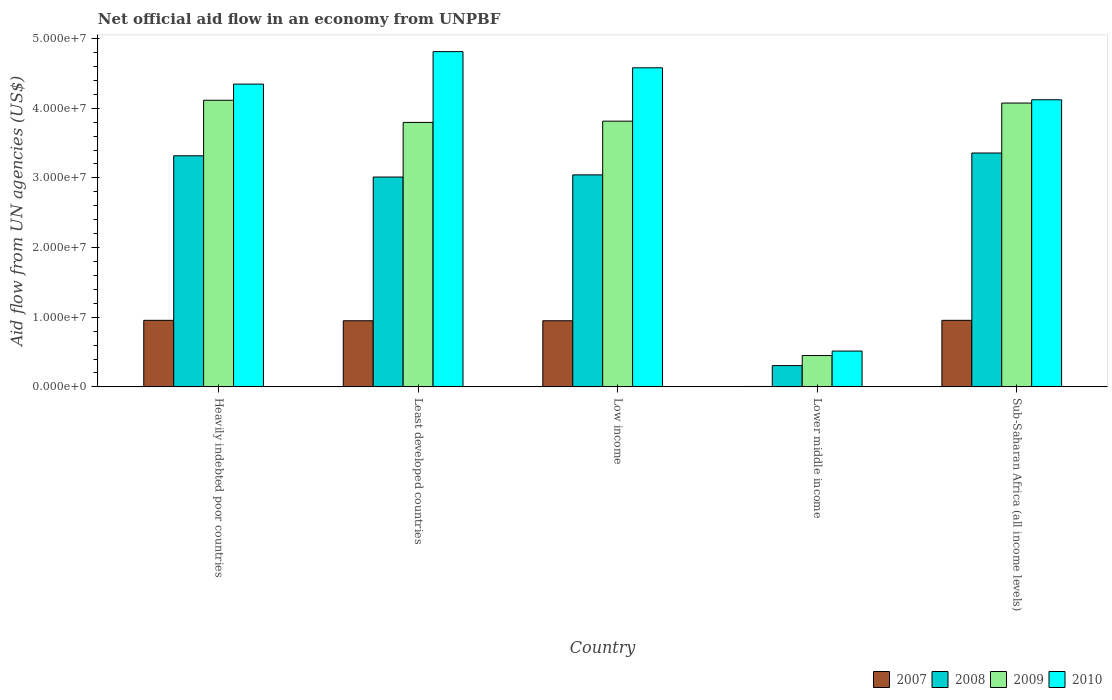Are the number of bars per tick equal to the number of legend labels?
Give a very brief answer. Yes. How many bars are there on the 2nd tick from the left?
Ensure brevity in your answer.  4. What is the label of the 4th group of bars from the left?
Your response must be concise. Lower middle income. In how many cases, is the number of bars for a given country not equal to the number of legend labels?
Offer a terse response. 0. What is the net official aid flow in 2008 in Least developed countries?
Provide a succinct answer. 3.01e+07. Across all countries, what is the maximum net official aid flow in 2009?
Your response must be concise. 4.11e+07. Across all countries, what is the minimum net official aid flow in 2009?
Make the answer very short. 4.50e+06. In which country was the net official aid flow in 2007 maximum?
Your answer should be very brief. Heavily indebted poor countries. In which country was the net official aid flow in 2010 minimum?
Provide a short and direct response. Lower middle income. What is the total net official aid flow in 2010 in the graph?
Your answer should be very brief. 1.84e+08. What is the difference between the net official aid flow in 2010 in Sub-Saharan Africa (all income levels) and the net official aid flow in 2008 in Least developed countries?
Keep it short and to the point. 1.11e+07. What is the average net official aid flow in 2007 per country?
Keep it short and to the point. 7.63e+06. What is the difference between the net official aid flow of/in 2009 and net official aid flow of/in 2010 in Sub-Saharan Africa (all income levels)?
Offer a very short reply. -4.70e+05. What is the ratio of the net official aid flow in 2010 in Heavily indebted poor countries to that in Least developed countries?
Your answer should be very brief. 0.9. Is the difference between the net official aid flow in 2009 in Lower middle income and Sub-Saharan Africa (all income levels) greater than the difference between the net official aid flow in 2010 in Lower middle income and Sub-Saharan Africa (all income levels)?
Offer a very short reply. No. What is the difference between the highest and the second highest net official aid flow in 2009?
Your answer should be very brief. 3.00e+06. What is the difference between the highest and the lowest net official aid flow in 2008?
Your response must be concise. 3.05e+07. In how many countries, is the net official aid flow in 2008 greater than the average net official aid flow in 2008 taken over all countries?
Your answer should be compact. 4. Is it the case that in every country, the sum of the net official aid flow in 2010 and net official aid flow in 2008 is greater than the sum of net official aid flow in 2007 and net official aid flow in 2009?
Your answer should be very brief. No. What does the 2nd bar from the left in Lower middle income represents?
Your answer should be compact. 2008. What does the 4th bar from the right in Heavily indebted poor countries represents?
Your answer should be compact. 2007. Is it the case that in every country, the sum of the net official aid flow in 2007 and net official aid flow in 2010 is greater than the net official aid flow in 2009?
Offer a terse response. Yes. What is the difference between two consecutive major ticks on the Y-axis?
Offer a terse response. 1.00e+07. Are the values on the major ticks of Y-axis written in scientific E-notation?
Provide a short and direct response. Yes. Does the graph contain any zero values?
Make the answer very short. No. Does the graph contain grids?
Your response must be concise. No. How many legend labels are there?
Provide a short and direct response. 4. What is the title of the graph?
Give a very brief answer. Net official aid flow in an economy from UNPBF. Does "2002" appear as one of the legend labels in the graph?
Offer a terse response. No. What is the label or title of the X-axis?
Your answer should be compact. Country. What is the label or title of the Y-axis?
Provide a short and direct response. Aid flow from UN agencies (US$). What is the Aid flow from UN agencies (US$) of 2007 in Heavily indebted poor countries?
Make the answer very short. 9.55e+06. What is the Aid flow from UN agencies (US$) in 2008 in Heavily indebted poor countries?
Give a very brief answer. 3.32e+07. What is the Aid flow from UN agencies (US$) of 2009 in Heavily indebted poor countries?
Provide a succinct answer. 4.11e+07. What is the Aid flow from UN agencies (US$) of 2010 in Heavily indebted poor countries?
Your answer should be very brief. 4.35e+07. What is the Aid flow from UN agencies (US$) in 2007 in Least developed countries?
Offer a very short reply. 9.49e+06. What is the Aid flow from UN agencies (US$) of 2008 in Least developed countries?
Your response must be concise. 3.01e+07. What is the Aid flow from UN agencies (US$) of 2009 in Least developed countries?
Your answer should be compact. 3.80e+07. What is the Aid flow from UN agencies (US$) in 2010 in Least developed countries?
Keep it short and to the point. 4.81e+07. What is the Aid flow from UN agencies (US$) in 2007 in Low income?
Your answer should be very brief. 9.49e+06. What is the Aid flow from UN agencies (US$) of 2008 in Low income?
Give a very brief answer. 3.04e+07. What is the Aid flow from UN agencies (US$) in 2009 in Low income?
Make the answer very short. 3.81e+07. What is the Aid flow from UN agencies (US$) of 2010 in Low income?
Ensure brevity in your answer.  4.58e+07. What is the Aid flow from UN agencies (US$) in 2007 in Lower middle income?
Give a very brief answer. 6.00e+04. What is the Aid flow from UN agencies (US$) in 2008 in Lower middle income?
Your answer should be very brief. 3.05e+06. What is the Aid flow from UN agencies (US$) of 2009 in Lower middle income?
Your response must be concise. 4.50e+06. What is the Aid flow from UN agencies (US$) in 2010 in Lower middle income?
Your answer should be compact. 5.14e+06. What is the Aid flow from UN agencies (US$) in 2007 in Sub-Saharan Africa (all income levels)?
Provide a succinct answer. 9.55e+06. What is the Aid flow from UN agencies (US$) in 2008 in Sub-Saharan Africa (all income levels)?
Offer a very short reply. 3.36e+07. What is the Aid flow from UN agencies (US$) of 2009 in Sub-Saharan Africa (all income levels)?
Give a very brief answer. 4.07e+07. What is the Aid flow from UN agencies (US$) of 2010 in Sub-Saharan Africa (all income levels)?
Provide a succinct answer. 4.12e+07. Across all countries, what is the maximum Aid flow from UN agencies (US$) in 2007?
Your answer should be compact. 9.55e+06. Across all countries, what is the maximum Aid flow from UN agencies (US$) in 2008?
Your answer should be compact. 3.36e+07. Across all countries, what is the maximum Aid flow from UN agencies (US$) in 2009?
Give a very brief answer. 4.11e+07. Across all countries, what is the maximum Aid flow from UN agencies (US$) of 2010?
Your answer should be compact. 4.81e+07. Across all countries, what is the minimum Aid flow from UN agencies (US$) in 2008?
Ensure brevity in your answer.  3.05e+06. Across all countries, what is the minimum Aid flow from UN agencies (US$) in 2009?
Your response must be concise. 4.50e+06. Across all countries, what is the minimum Aid flow from UN agencies (US$) of 2010?
Offer a terse response. 5.14e+06. What is the total Aid flow from UN agencies (US$) of 2007 in the graph?
Make the answer very short. 3.81e+07. What is the total Aid flow from UN agencies (US$) in 2008 in the graph?
Your response must be concise. 1.30e+08. What is the total Aid flow from UN agencies (US$) of 2009 in the graph?
Your answer should be compact. 1.62e+08. What is the total Aid flow from UN agencies (US$) of 2010 in the graph?
Your answer should be very brief. 1.84e+08. What is the difference between the Aid flow from UN agencies (US$) in 2008 in Heavily indebted poor countries and that in Least developed countries?
Provide a short and direct response. 3.05e+06. What is the difference between the Aid flow from UN agencies (US$) in 2009 in Heavily indebted poor countries and that in Least developed countries?
Ensure brevity in your answer.  3.18e+06. What is the difference between the Aid flow from UN agencies (US$) of 2010 in Heavily indebted poor countries and that in Least developed countries?
Ensure brevity in your answer.  -4.66e+06. What is the difference between the Aid flow from UN agencies (US$) of 2007 in Heavily indebted poor countries and that in Low income?
Your answer should be compact. 6.00e+04. What is the difference between the Aid flow from UN agencies (US$) of 2008 in Heavily indebted poor countries and that in Low income?
Ensure brevity in your answer.  2.74e+06. What is the difference between the Aid flow from UN agencies (US$) of 2010 in Heavily indebted poor countries and that in Low income?
Your response must be concise. -2.34e+06. What is the difference between the Aid flow from UN agencies (US$) in 2007 in Heavily indebted poor countries and that in Lower middle income?
Offer a very short reply. 9.49e+06. What is the difference between the Aid flow from UN agencies (US$) in 2008 in Heavily indebted poor countries and that in Lower middle income?
Provide a short and direct response. 3.01e+07. What is the difference between the Aid flow from UN agencies (US$) in 2009 in Heavily indebted poor countries and that in Lower middle income?
Keep it short and to the point. 3.66e+07. What is the difference between the Aid flow from UN agencies (US$) in 2010 in Heavily indebted poor countries and that in Lower middle income?
Your answer should be very brief. 3.83e+07. What is the difference between the Aid flow from UN agencies (US$) in 2008 in Heavily indebted poor countries and that in Sub-Saharan Africa (all income levels)?
Your response must be concise. -4.00e+05. What is the difference between the Aid flow from UN agencies (US$) in 2009 in Heavily indebted poor countries and that in Sub-Saharan Africa (all income levels)?
Provide a succinct answer. 4.00e+05. What is the difference between the Aid flow from UN agencies (US$) in 2010 in Heavily indebted poor countries and that in Sub-Saharan Africa (all income levels)?
Your answer should be very brief. 2.25e+06. What is the difference between the Aid flow from UN agencies (US$) of 2007 in Least developed countries and that in Low income?
Your answer should be very brief. 0. What is the difference between the Aid flow from UN agencies (US$) in 2008 in Least developed countries and that in Low income?
Provide a short and direct response. -3.10e+05. What is the difference between the Aid flow from UN agencies (US$) in 2009 in Least developed countries and that in Low income?
Keep it short and to the point. -1.80e+05. What is the difference between the Aid flow from UN agencies (US$) in 2010 in Least developed countries and that in Low income?
Provide a short and direct response. 2.32e+06. What is the difference between the Aid flow from UN agencies (US$) in 2007 in Least developed countries and that in Lower middle income?
Offer a very short reply. 9.43e+06. What is the difference between the Aid flow from UN agencies (US$) of 2008 in Least developed countries and that in Lower middle income?
Offer a terse response. 2.71e+07. What is the difference between the Aid flow from UN agencies (US$) of 2009 in Least developed countries and that in Lower middle income?
Your answer should be compact. 3.35e+07. What is the difference between the Aid flow from UN agencies (US$) of 2010 in Least developed countries and that in Lower middle income?
Provide a short and direct response. 4.30e+07. What is the difference between the Aid flow from UN agencies (US$) in 2008 in Least developed countries and that in Sub-Saharan Africa (all income levels)?
Your answer should be compact. -3.45e+06. What is the difference between the Aid flow from UN agencies (US$) of 2009 in Least developed countries and that in Sub-Saharan Africa (all income levels)?
Give a very brief answer. -2.78e+06. What is the difference between the Aid flow from UN agencies (US$) of 2010 in Least developed countries and that in Sub-Saharan Africa (all income levels)?
Ensure brevity in your answer.  6.91e+06. What is the difference between the Aid flow from UN agencies (US$) of 2007 in Low income and that in Lower middle income?
Your answer should be compact. 9.43e+06. What is the difference between the Aid flow from UN agencies (US$) in 2008 in Low income and that in Lower middle income?
Offer a very short reply. 2.74e+07. What is the difference between the Aid flow from UN agencies (US$) in 2009 in Low income and that in Lower middle income?
Your answer should be compact. 3.36e+07. What is the difference between the Aid flow from UN agencies (US$) in 2010 in Low income and that in Lower middle income?
Provide a short and direct response. 4.07e+07. What is the difference between the Aid flow from UN agencies (US$) in 2008 in Low income and that in Sub-Saharan Africa (all income levels)?
Your answer should be compact. -3.14e+06. What is the difference between the Aid flow from UN agencies (US$) of 2009 in Low income and that in Sub-Saharan Africa (all income levels)?
Ensure brevity in your answer.  -2.60e+06. What is the difference between the Aid flow from UN agencies (US$) of 2010 in Low income and that in Sub-Saharan Africa (all income levels)?
Your answer should be compact. 4.59e+06. What is the difference between the Aid flow from UN agencies (US$) in 2007 in Lower middle income and that in Sub-Saharan Africa (all income levels)?
Offer a terse response. -9.49e+06. What is the difference between the Aid flow from UN agencies (US$) in 2008 in Lower middle income and that in Sub-Saharan Africa (all income levels)?
Keep it short and to the point. -3.05e+07. What is the difference between the Aid flow from UN agencies (US$) in 2009 in Lower middle income and that in Sub-Saharan Africa (all income levels)?
Provide a succinct answer. -3.62e+07. What is the difference between the Aid flow from UN agencies (US$) of 2010 in Lower middle income and that in Sub-Saharan Africa (all income levels)?
Your response must be concise. -3.61e+07. What is the difference between the Aid flow from UN agencies (US$) of 2007 in Heavily indebted poor countries and the Aid flow from UN agencies (US$) of 2008 in Least developed countries?
Provide a succinct answer. -2.06e+07. What is the difference between the Aid flow from UN agencies (US$) in 2007 in Heavily indebted poor countries and the Aid flow from UN agencies (US$) in 2009 in Least developed countries?
Give a very brief answer. -2.84e+07. What is the difference between the Aid flow from UN agencies (US$) of 2007 in Heavily indebted poor countries and the Aid flow from UN agencies (US$) of 2010 in Least developed countries?
Provide a succinct answer. -3.86e+07. What is the difference between the Aid flow from UN agencies (US$) in 2008 in Heavily indebted poor countries and the Aid flow from UN agencies (US$) in 2009 in Least developed countries?
Offer a very short reply. -4.79e+06. What is the difference between the Aid flow from UN agencies (US$) in 2008 in Heavily indebted poor countries and the Aid flow from UN agencies (US$) in 2010 in Least developed countries?
Ensure brevity in your answer.  -1.50e+07. What is the difference between the Aid flow from UN agencies (US$) of 2009 in Heavily indebted poor countries and the Aid flow from UN agencies (US$) of 2010 in Least developed countries?
Give a very brief answer. -6.98e+06. What is the difference between the Aid flow from UN agencies (US$) in 2007 in Heavily indebted poor countries and the Aid flow from UN agencies (US$) in 2008 in Low income?
Offer a terse response. -2.09e+07. What is the difference between the Aid flow from UN agencies (US$) in 2007 in Heavily indebted poor countries and the Aid flow from UN agencies (US$) in 2009 in Low income?
Provide a succinct answer. -2.86e+07. What is the difference between the Aid flow from UN agencies (US$) of 2007 in Heavily indebted poor countries and the Aid flow from UN agencies (US$) of 2010 in Low income?
Provide a succinct answer. -3.62e+07. What is the difference between the Aid flow from UN agencies (US$) of 2008 in Heavily indebted poor countries and the Aid flow from UN agencies (US$) of 2009 in Low income?
Your response must be concise. -4.97e+06. What is the difference between the Aid flow from UN agencies (US$) in 2008 in Heavily indebted poor countries and the Aid flow from UN agencies (US$) in 2010 in Low income?
Keep it short and to the point. -1.26e+07. What is the difference between the Aid flow from UN agencies (US$) in 2009 in Heavily indebted poor countries and the Aid flow from UN agencies (US$) in 2010 in Low income?
Provide a short and direct response. -4.66e+06. What is the difference between the Aid flow from UN agencies (US$) in 2007 in Heavily indebted poor countries and the Aid flow from UN agencies (US$) in 2008 in Lower middle income?
Ensure brevity in your answer.  6.50e+06. What is the difference between the Aid flow from UN agencies (US$) in 2007 in Heavily indebted poor countries and the Aid flow from UN agencies (US$) in 2009 in Lower middle income?
Your answer should be very brief. 5.05e+06. What is the difference between the Aid flow from UN agencies (US$) in 2007 in Heavily indebted poor countries and the Aid flow from UN agencies (US$) in 2010 in Lower middle income?
Provide a short and direct response. 4.41e+06. What is the difference between the Aid flow from UN agencies (US$) of 2008 in Heavily indebted poor countries and the Aid flow from UN agencies (US$) of 2009 in Lower middle income?
Your answer should be very brief. 2.87e+07. What is the difference between the Aid flow from UN agencies (US$) of 2008 in Heavily indebted poor countries and the Aid flow from UN agencies (US$) of 2010 in Lower middle income?
Provide a succinct answer. 2.80e+07. What is the difference between the Aid flow from UN agencies (US$) of 2009 in Heavily indebted poor countries and the Aid flow from UN agencies (US$) of 2010 in Lower middle income?
Provide a succinct answer. 3.60e+07. What is the difference between the Aid flow from UN agencies (US$) of 2007 in Heavily indebted poor countries and the Aid flow from UN agencies (US$) of 2008 in Sub-Saharan Africa (all income levels)?
Offer a very short reply. -2.40e+07. What is the difference between the Aid flow from UN agencies (US$) in 2007 in Heavily indebted poor countries and the Aid flow from UN agencies (US$) in 2009 in Sub-Saharan Africa (all income levels)?
Provide a short and direct response. -3.12e+07. What is the difference between the Aid flow from UN agencies (US$) of 2007 in Heavily indebted poor countries and the Aid flow from UN agencies (US$) of 2010 in Sub-Saharan Africa (all income levels)?
Ensure brevity in your answer.  -3.17e+07. What is the difference between the Aid flow from UN agencies (US$) of 2008 in Heavily indebted poor countries and the Aid flow from UN agencies (US$) of 2009 in Sub-Saharan Africa (all income levels)?
Give a very brief answer. -7.57e+06. What is the difference between the Aid flow from UN agencies (US$) of 2008 in Heavily indebted poor countries and the Aid flow from UN agencies (US$) of 2010 in Sub-Saharan Africa (all income levels)?
Ensure brevity in your answer.  -8.04e+06. What is the difference between the Aid flow from UN agencies (US$) in 2007 in Least developed countries and the Aid flow from UN agencies (US$) in 2008 in Low income?
Make the answer very short. -2.09e+07. What is the difference between the Aid flow from UN agencies (US$) in 2007 in Least developed countries and the Aid flow from UN agencies (US$) in 2009 in Low income?
Make the answer very short. -2.86e+07. What is the difference between the Aid flow from UN agencies (US$) of 2007 in Least developed countries and the Aid flow from UN agencies (US$) of 2010 in Low income?
Ensure brevity in your answer.  -3.63e+07. What is the difference between the Aid flow from UN agencies (US$) of 2008 in Least developed countries and the Aid flow from UN agencies (US$) of 2009 in Low income?
Your response must be concise. -8.02e+06. What is the difference between the Aid flow from UN agencies (US$) of 2008 in Least developed countries and the Aid flow from UN agencies (US$) of 2010 in Low income?
Give a very brief answer. -1.57e+07. What is the difference between the Aid flow from UN agencies (US$) in 2009 in Least developed countries and the Aid flow from UN agencies (US$) in 2010 in Low income?
Provide a short and direct response. -7.84e+06. What is the difference between the Aid flow from UN agencies (US$) in 2007 in Least developed countries and the Aid flow from UN agencies (US$) in 2008 in Lower middle income?
Offer a very short reply. 6.44e+06. What is the difference between the Aid flow from UN agencies (US$) in 2007 in Least developed countries and the Aid flow from UN agencies (US$) in 2009 in Lower middle income?
Offer a very short reply. 4.99e+06. What is the difference between the Aid flow from UN agencies (US$) of 2007 in Least developed countries and the Aid flow from UN agencies (US$) of 2010 in Lower middle income?
Provide a short and direct response. 4.35e+06. What is the difference between the Aid flow from UN agencies (US$) in 2008 in Least developed countries and the Aid flow from UN agencies (US$) in 2009 in Lower middle income?
Provide a short and direct response. 2.56e+07. What is the difference between the Aid flow from UN agencies (US$) in 2008 in Least developed countries and the Aid flow from UN agencies (US$) in 2010 in Lower middle income?
Provide a succinct answer. 2.50e+07. What is the difference between the Aid flow from UN agencies (US$) in 2009 in Least developed countries and the Aid flow from UN agencies (US$) in 2010 in Lower middle income?
Give a very brief answer. 3.28e+07. What is the difference between the Aid flow from UN agencies (US$) of 2007 in Least developed countries and the Aid flow from UN agencies (US$) of 2008 in Sub-Saharan Africa (all income levels)?
Keep it short and to the point. -2.41e+07. What is the difference between the Aid flow from UN agencies (US$) in 2007 in Least developed countries and the Aid flow from UN agencies (US$) in 2009 in Sub-Saharan Africa (all income levels)?
Provide a succinct answer. -3.12e+07. What is the difference between the Aid flow from UN agencies (US$) in 2007 in Least developed countries and the Aid flow from UN agencies (US$) in 2010 in Sub-Saharan Africa (all income levels)?
Make the answer very short. -3.17e+07. What is the difference between the Aid flow from UN agencies (US$) of 2008 in Least developed countries and the Aid flow from UN agencies (US$) of 2009 in Sub-Saharan Africa (all income levels)?
Give a very brief answer. -1.06e+07. What is the difference between the Aid flow from UN agencies (US$) of 2008 in Least developed countries and the Aid flow from UN agencies (US$) of 2010 in Sub-Saharan Africa (all income levels)?
Ensure brevity in your answer.  -1.11e+07. What is the difference between the Aid flow from UN agencies (US$) in 2009 in Least developed countries and the Aid flow from UN agencies (US$) in 2010 in Sub-Saharan Africa (all income levels)?
Keep it short and to the point. -3.25e+06. What is the difference between the Aid flow from UN agencies (US$) of 2007 in Low income and the Aid flow from UN agencies (US$) of 2008 in Lower middle income?
Give a very brief answer. 6.44e+06. What is the difference between the Aid flow from UN agencies (US$) in 2007 in Low income and the Aid flow from UN agencies (US$) in 2009 in Lower middle income?
Give a very brief answer. 4.99e+06. What is the difference between the Aid flow from UN agencies (US$) of 2007 in Low income and the Aid flow from UN agencies (US$) of 2010 in Lower middle income?
Offer a very short reply. 4.35e+06. What is the difference between the Aid flow from UN agencies (US$) of 2008 in Low income and the Aid flow from UN agencies (US$) of 2009 in Lower middle income?
Give a very brief answer. 2.59e+07. What is the difference between the Aid flow from UN agencies (US$) of 2008 in Low income and the Aid flow from UN agencies (US$) of 2010 in Lower middle income?
Your answer should be very brief. 2.53e+07. What is the difference between the Aid flow from UN agencies (US$) of 2009 in Low income and the Aid flow from UN agencies (US$) of 2010 in Lower middle income?
Keep it short and to the point. 3.30e+07. What is the difference between the Aid flow from UN agencies (US$) in 2007 in Low income and the Aid flow from UN agencies (US$) in 2008 in Sub-Saharan Africa (all income levels)?
Offer a terse response. -2.41e+07. What is the difference between the Aid flow from UN agencies (US$) of 2007 in Low income and the Aid flow from UN agencies (US$) of 2009 in Sub-Saharan Africa (all income levels)?
Offer a very short reply. -3.12e+07. What is the difference between the Aid flow from UN agencies (US$) in 2007 in Low income and the Aid flow from UN agencies (US$) in 2010 in Sub-Saharan Africa (all income levels)?
Offer a terse response. -3.17e+07. What is the difference between the Aid flow from UN agencies (US$) in 2008 in Low income and the Aid flow from UN agencies (US$) in 2009 in Sub-Saharan Africa (all income levels)?
Keep it short and to the point. -1.03e+07. What is the difference between the Aid flow from UN agencies (US$) in 2008 in Low income and the Aid flow from UN agencies (US$) in 2010 in Sub-Saharan Africa (all income levels)?
Give a very brief answer. -1.08e+07. What is the difference between the Aid flow from UN agencies (US$) of 2009 in Low income and the Aid flow from UN agencies (US$) of 2010 in Sub-Saharan Africa (all income levels)?
Your response must be concise. -3.07e+06. What is the difference between the Aid flow from UN agencies (US$) of 2007 in Lower middle income and the Aid flow from UN agencies (US$) of 2008 in Sub-Saharan Africa (all income levels)?
Your response must be concise. -3.35e+07. What is the difference between the Aid flow from UN agencies (US$) in 2007 in Lower middle income and the Aid flow from UN agencies (US$) in 2009 in Sub-Saharan Africa (all income levels)?
Your answer should be very brief. -4.07e+07. What is the difference between the Aid flow from UN agencies (US$) in 2007 in Lower middle income and the Aid flow from UN agencies (US$) in 2010 in Sub-Saharan Africa (all income levels)?
Your response must be concise. -4.12e+07. What is the difference between the Aid flow from UN agencies (US$) in 2008 in Lower middle income and the Aid flow from UN agencies (US$) in 2009 in Sub-Saharan Africa (all income levels)?
Your response must be concise. -3.77e+07. What is the difference between the Aid flow from UN agencies (US$) of 2008 in Lower middle income and the Aid flow from UN agencies (US$) of 2010 in Sub-Saharan Africa (all income levels)?
Your answer should be very brief. -3.82e+07. What is the difference between the Aid flow from UN agencies (US$) in 2009 in Lower middle income and the Aid flow from UN agencies (US$) in 2010 in Sub-Saharan Africa (all income levels)?
Your answer should be very brief. -3.67e+07. What is the average Aid flow from UN agencies (US$) in 2007 per country?
Your response must be concise. 7.63e+06. What is the average Aid flow from UN agencies (US$) of 2008 per country?
Offer a terse response. 2.61e+07. What is the average Aid flow from UN agencies (US$) of 2009 per country?
Ensure brevity in your answer.  3.25e+07. What is the average Aid flow from UN agencies (US$) of 2010 per country?
Make the answer very short. 3.67e+07. What is the difference between the Aid flow from UN agencies (US$) in 2007 and Aid flow from UN agencies (US$) in 2008 in Heavily indebted poor countries?
Provide a short and direct response. -2.36e+07. What is the difference between the Aid flow from UN agencies (US$) of 2007 and Aid flow from UN agencies (US$) of 2009 in Heavily indebted poor countries?
Provide a short and direct response. -3.16e+07. What is the difference between the Aid flow from UN agencies (US$) of 2007 and Aid flow from UN agencies (US$) of 2010 in Heavily indebted poor countries?
Offer a very short reply. -3.39e+07. What is the difference between the Aid flow from UN agencies (US$) in 2008 and Aid flow from UN agencies (US$) in 2009 in Heavily indebted poor countries?
Keep it short and to the point. -7.97e+06. What is the difference between the Aid flow from UN agencies (US$) in 2008 and Aid flow from UN agencies (US$) in 2010 in Heavily indebted poor countries?
Give a very brief answer. -1.03e+07. What is the difference between the Aid flow from UN agencies (US$) of 2009 and Aid flow from UN agencies (US$) of 2010 in Heavily indebted poor countries?
Your answer should be very brief. -2.32e+06. What is the difference between the Aid flow from UN agencies (US$) in 2007 and Aid flow from UN agencies (US$) in 2008 in Least developed countries?
Your answer should be very brief. -2.06e+07. What is the difference between the Aid flow from UN agencies (US$) of 2007 and Aid flow from UN agencies (US$) of 2009 in Least developed countries?
Your answer should be compact. -2.85e+07. What is the difference between the Aid flow from UN agencies (US$) in 2007 and Aid flow from UN agencies (US$) in 2010 in Least developed countries?
Provide a short and direct response. -3.86e+07. What is the difference between the Aid flow from UN agencies (US$) in 2008 and Aid flow from UN agencies (US$) in 2009 in Least developed countries?
Provide a succinct answer. -7.84e+06. What is the difference between the Aid flow from UN agencies (US$) in 2008 and Aid flow from UN agencies (US$) in 2010 in Least developed countries?
Offer a terse response. -1.80e+07. What is the difference between the Aid flow from UN agencies (US$) of 2009 and Aid flow from UN agencies (US$) of 2010 in Least developed countries?
Provide a succinct answer. -1.02e+07. What is the difference between the Aid flow from UN agencies (US$) of 2007 and Aid flow from UN agencies (US$) of 2008 in Low income?
Ensure brevity in your answer.  -2.09e+07. What is the difference between the Aid flow from UN agencies (US$) of 2007 and Aid flow from UN agencies (US$) of 2009 in Low income?
Your response must be concise. -2.86e+07. What is the difference between the Aid flow from UN agencies (US$) in 2007 and Aid flow from UN agencies (US$) in 2010 in Low income?
Your response must be concise. -3.63e+07. What is the difference between the Aid flow from UN agencies (US$) in 2008 and Aid flow from UN agencies (US$) in 2009 in Low income?
Your answer should be compact. -7.71e+06. What is the difference between the Aid flow from UN agencies (US$) of 2008 and Aid flow from UN agencies (US$) of 2010 in Low income?
Your response must be concise. -1.54e+07. What is the difference between the Aid flow from UN agencies (US$) in 2009 and Aid flow from UN agencies (US$) in 2010 in Low income?
Your response must be concise. -7.66e+06. What is the difference between the Aid flow from UN agencies (US$) in 2007 and Aid flow from UN agencies (US$) in 2008 in Lower middle income?
Offer a terse response. -2.99e+06. What is the difference between the Aid flow from UN agencies (US$) of 2007 and Aid flow from UN agencies (US$) of 2009 in Lower middle income?
Offer a very short reply. -4.44e+06. What is the difference between the Aid flow from UN agencies (US$) in 2007 and Aid flow from UN agencies (US$) in 2010 in Lower middle income?
Make the answer very short. -5.08e+06. What is the difference between the Aid flow from UN agencies (US$) of 2008 and Aid flow from UN agencies (US$) of 2009 in Lower middle income?
Your response must be concise. -1.45e+06. What is the difference between the Aid flow from UN agencies (US$) in 2008 and Aid flow from UN agencies (US$) in 2010 in Lower middle income?
Offer a terse response. -2.09e+06. What is the difference between the Aid flow from UN agencies (US$) of 2009 and Aid flow from UN agencies (US$) of 2010 in Lower middle income?
Keep it short and to the point. -6.40e+05. What is the difference between the Aid flow from UN agencies (US$) in 2007 and Aid flow from UN agencies (US$) in 2008 in Sub-Saharan Africa (all income levels)?
Your answer should be compact. -2.40e+07. What is the difference between the Aid flow from UN agencies (US$) in 2007 and Aid flow from UN agencies (US$) in 2009 in Sub-Saharan Africa (all income levels)?
Offer a terse response. -3.12e+07. What is the difference between the Aid flow from UN agencies (US$) of 2007 and Aid flow from UN agencies (US$) of 2010 in Sub-Saharan Africa (all income levels)?
Ensure brevity in your answer.  -3.17e+07. What is the difference between the Aid flow from UN agencies (US$) in 2008 and Aid flow from UN agencies (US$) in 2009 in Sub-Saharan Africa (all income levels)?
Ensure brevity in your answer.  -7.17e+06. What is the difference between the Aid flow from UN agencies (US$) in 2008 and Aid flow from UN agencies (US$) in 2010 in Sub-Saharan Africa (all income levels)?
Your answer should be compact. -7.64e+06. What is the difference between the Aid flow from UN agencies (US$) in 2009 and Aid flow from UN agencies (US$) in 2010 in Sub-Saharan Africa (all income levels)?
Your response must be concise. -4.70e+05. What is the ratio of the Aid flow from UN agencies (US$) in 2007 in Heavily indebted poor countries to that in Least developed countries?
Make the answer very short. 1.01. What is the ratio of the Aid flow from UN agencies (US$) of 2008 in Heavily indebted poor countries to that in Least developed countries?
Provide a short and direct response. 1.1. What is the ratio of the Aid flow from UN agencies (US$) of 2009 in Heavily indebted poor countries to that in Least developed countries?
Provide a short and direct response. 1.08. What is the ratio of the Aid flow from UN agencies (US$) of 2010 in Heavily indebted poor countries to that in Least developed countries?
Offer a very short reply. 0.9. What is the ratio of the Aid flow from UN agencies (US$) of 2007 in Heavily indebted poor countries to that in Low income?
Your answer should be very brief. 1.01. What is the ratio of the Aid flow from UN agencies (US$) of 2008 in Heavily indebted poor countries to that in Low income?
Your answer should be very brief. 1.09. What is the ratio of the Aid flow from UN agencies (US$) of 2009 in Heavily indebted poor countries to that in Low income?
Offer a very short reply. 1.08. What is the ratio of the Aid flow from UN agencies (US$) in 2010 in Heavily indebted poor countries to that in Low income?
Provide a short and direct response. 0.95. What is the ratio of the Aid flow from UN agencies (US$) of 2007 in Heavily indebted poor countries to that in Lower middle income?
Provide a succinct answer. 159.17. What is the ratio of the Aid flow from UN agencies (US$) in 2008 in Heavily indebted poor countries to that in Lower middle income?
Provide a succinct answer. 10.88. What is the ratio of the Aid flow from UN agencies (US$) in 2009 in Heavily indebted poor countries to that in Lower middle income?
Your answer should be compact. 9.14. What is the ratio of the Aid flow from UN agencies (US$) in 2010 in Heavily indebted poor countries to that in Lower middle income?
Offer a terse response. 8.46. What is the ratio of the Aid flow from UN agencies (US$) in 2009 in Heavily indebted poor countries to that in Sub-Saharan Africa (all income levels)?
Provide a short and direct response. 1.01. What is the ratio of the Aid flow from UN agencies (US$) of 2010 in Heavily indebted poor countries to that in Sub-Saharan Africa (all income levels)?
Your answer should be compact. 1.05. What is the ratio of the Aid flow from UN agencies (US$) in 2007 in Least developed countries to that in Low income?
Give a very brief answer. 1. What is the ratio of the Aid flow from UN agencies (US$) in 2009 in Least developed countries to that in Low income?
Make the answer very short. 1. What is the ratio of the Aid flow from UN agencies (US$) in 2010 in Least developed countries to that in Low income?
Offer a very short reply. 1.05. What is the ratio of the Aid flow from UN agencies (US$) of 2007 in Least developed countries to that in Lower middle income?
Provide a succinct answer. 158.17. What is the ratio of the Aid flow from UN agencies (US$) in 2008 in Least developed countries to that in Lower middle income?
Your response must be concise. 9.88. What is the ratio of the Aid flow from UN agencies (US$) of 2009 in Least developed countries to that in Lower middle income?
Offer a very short reply. 8.44. What is the ratio of the Aid flow from UN agencies (US$) of 2010 in Least developed countries to that in Lower middle income?
Offer a very short reply. 9.36. What is the ratio of the Aid flow from UN agencies (US$) in 2008 in Least developed countries to that in Sub-Saharan Africa (all income levels)?
Your answer should be very brief. 0.9. What is the ratio of the Aid flow from UN agencies (US$) of 2009 in Least developed countries to that in Sub-Saharan Africa (all income levels)?
Provide a succinct answer. 0.93. What is the ratio of the Aid flow from UN agencies (US$) in 2010 in Least developed countries to that in Sub-Saharan Africa (all income levels)?
Give a very brief answer. 1.17. What is the ratio of the Aid flow from UN agencies (US$) in 2007 in Low income to that in Lower middle income?
Your answer should be very brief. 158.17. What is the ratio of the Aid flow from UN agencies (US$) in 2008 in Low income to that in Lower middle income?
Give a very brief answer. 9.98. What is the ratio of the Aid flow from UN agencies (US$) in 2009 in Low income to that in Lower middle income?
Keep it short and to the point. 8.48. What is the ratio of the Aid flow from UN agencies (US$) of 2010 in Low income to that in Lower middle income?
Offer a very short reply. 8.91. What is the ratio of the Aid flow from UN agencies (US$) in 2007 in Low income to that in Sub-Saharan Africa (all income levels)?
Offer a terse response. 0.99. What is the ratio of the Aid flow from UN agencies (US$) of 2008 in Low income to that in Sub-Saharan Africa (all income levels)?
Provide a succinct answer. 0.91. What is the ratio of the Aid flow from UN agencies (US$) in 2009 in Low income to that in Sub-Saharan Africa (all income levels)?
Your answer should be compact. 0.94. What is the ratio of the Aid flow from UN agencies (US$) of 2010 in Low income to that in Sub-Saharan Africa (all income levels)?
Keep it short and to the point. 1.11. What is the ratio of the Aid flow from UN agencies (US$) of 2007 in Lower middle income to that in Sub-Saharan Africa (all income levels)?
Offer a very short reply. 0.01. What is the ratio of the Aid flow from UN agencies (US$) in 2008 in Lower middle income to that in Sub-Saharan Africa (all income levels)?
Your response must be concise. 0.09. What is the ratio of the Aid flow from UN agencies (US$) in 2009 in Lower middle income to that in Sub-Saharan Africa (all income levels)?
Your response must be concise. 0.11. What is the ratio of the Aid flow from UN agencies (US$) of 2010 in Lower middle income to that in Sub-Saharan Africa (all income levels)?
Make the answer very short. 0.12. What is the difference between the highest and the second highest Aid flow from UN agencies (US$) in 2007?
Keep it short and to the point. 0. What is the difference between the highest and the second highest Aid flow from UN agencies (US$) in 2008?
Ensure brevity in your answer.  4.00e+05. What is the difference between the highest and the second highest Aid flow from UN agencies (US$) of 2009?
Provide a short and direct response. 4.00e+05. What is the difference between the highest and the second highest Aid flow from UN agencies (US$) in 2010?
Your response must be concise. 2.32e+06. What is the difference between the highest and the lowest Aid flow from UN agencies (US$) in 2007?
Keep it short and to the point. 9.49e+06. What is the difference between the highest and the lowest Aid flow from UN agencies (US$) of 2008?
Provide a short and direct response. 3.05e+07. What is the difference between the highest and the lowest Aid flow from UN agencies (US$) in 2009?
Offer a terse response. 3.66e+07. What is the difference between the highest and the lowest Aid flow from UN agencies (US$) in 2010?
Provide a succinct answer. 4.30e+07. 